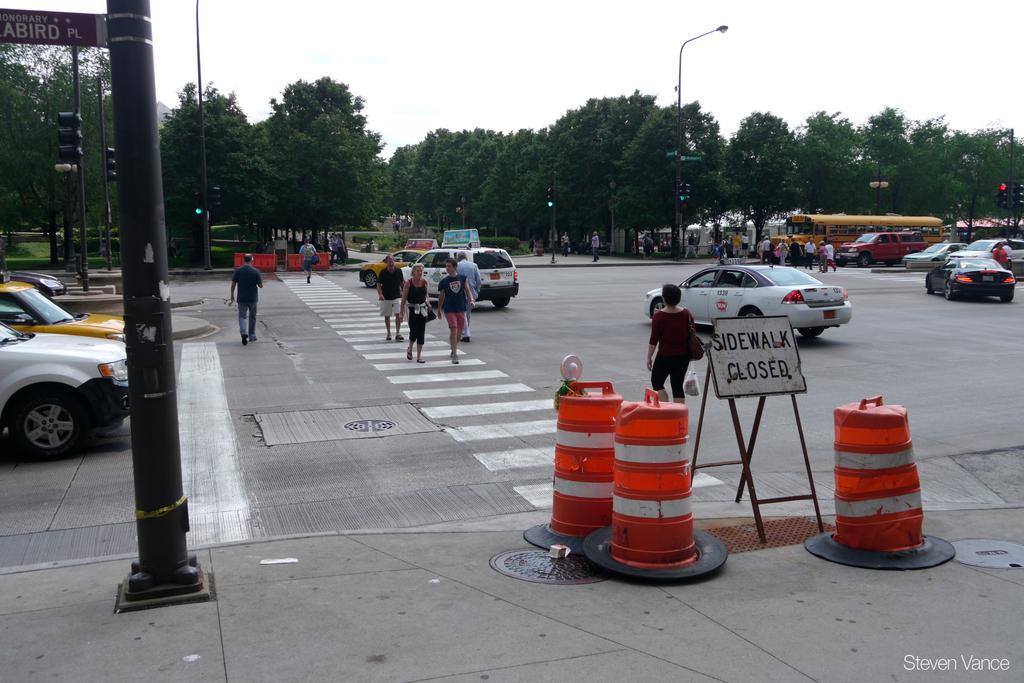In one or two sentences, can you explain what this image depicts? This picture is clicked outside the city. In this picture, we see people are crossing the road. Beside them, we see cars which are moving on the road. In front of the picture, we see traffic stoppers and a board in white color with some text written on it. On the left side, we see a pole and beside that, we see cars on the road. There are people walking on the road. We even see vehicles moving on the road. There are trees and street lights in the background. At the top of the picture, we see the sky. 